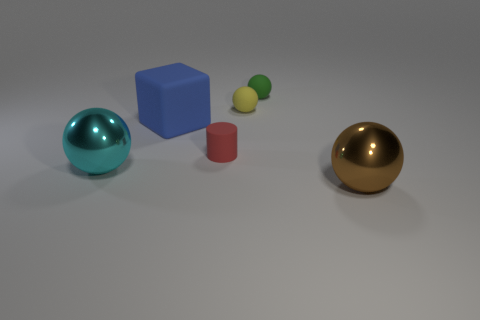Is the cyan ball made of the same material as the big blue object?
Keep it short and to the point. No. How many big objects are rubber balls or gray matte cubes?
Give a very brief answer. 0. Is there any other thing that has the same shape as the blue thing?
Your answer should be compact. No. Are there any other things that are the same size as the brown sphere?
Offer a very short reply. Yes. The big object that is the same material as the green ball is what color?
Keep it short and to the point. Blue. There is a large object that is left of the blue thing; what color is it?
Keep it short and to the point. Cyan. Are there fewer small red rubber objects behind the large blue block than rubber things that are to the right of the yellow matte ball?
Keep it short and to the point. Yes. There is a large cube; how many green matte things are in front of it?
Your answer should be compact. 0. Is there a small green sphere that has the same material as the brown object?
Keep it short and to the point. No. Are there more large blue objects behind the green sphere than big cyan shiny things that are right of the big brown sphere?
Make the answer very short. No. 